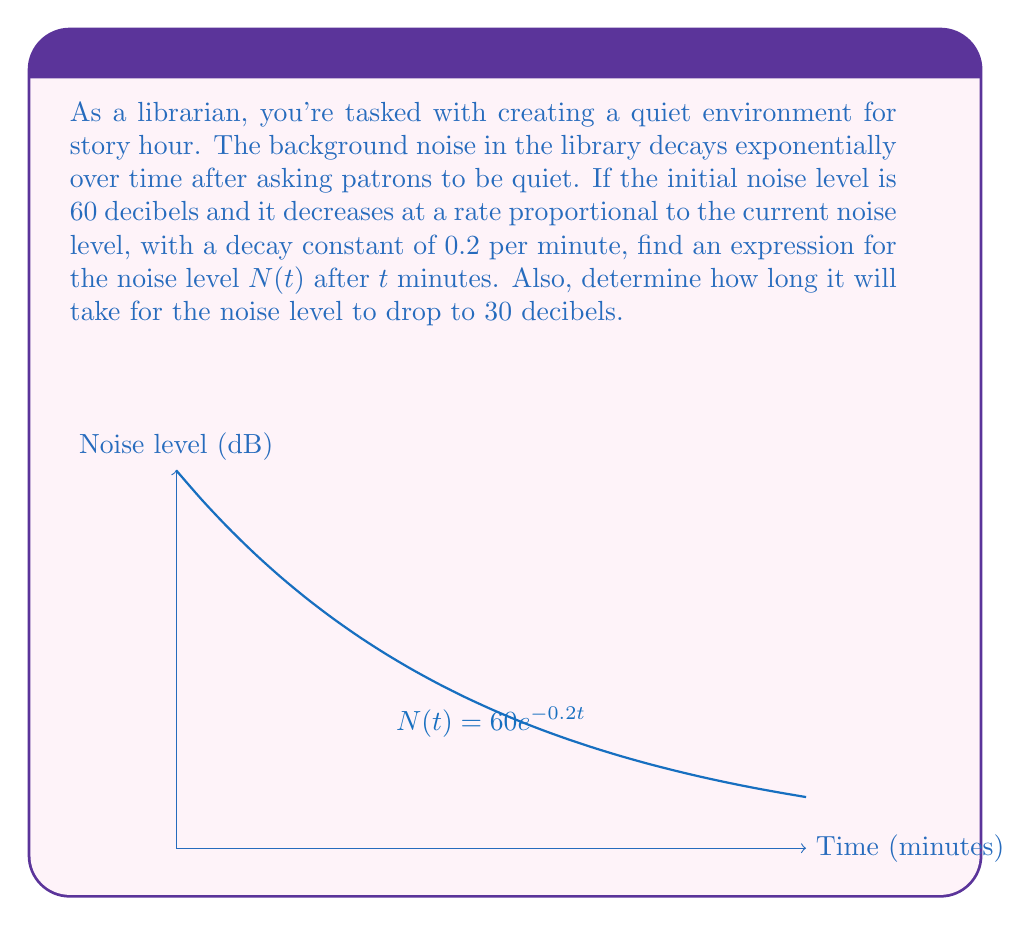Can you solve this math problem? Let's approach this step-by-step:

1) The rate of change of noise level is proportional to the current noise level. This can be expressed as:

   $$\frac{dN}{dt} = -kN$$

   where $k$ is the decay constant (0.2 per minute in this case).

2) This is a separable differential equation. Let's separate the variables:

   $$\frac{dN}{N} = -k dt$$

3) Integrate both sides:

   $$\int \frac{dN}{N} = -k \int dt$$

   $$\ln|N| = -kt + C$$

4) Solve for $N$:

   $$N = e^{-kt + C} = e^C \cdot e^{-kt}$$

5) Let $A = e^C$. Then our general solution is:

   $$N(t) = Ae^{-kt}$$

6) Use the initial condition: when $t=0$, $N=60$:

   $$60 = Ae^{-k(0)} = A$$

7) Therefore, our specific solution is:

   $$N(t) = 60e^{-0.2t}$$

8) To find when the noise level drops to 30 dB, solve:

   $$30 = 60e^{-0.2t}$$
   $$\frac{1}{2} = e^{-0.2t}$$
   $$\ln(\frac{1}{2}) = -0.2t$$
   $$t = -\frac{\ln(\frac{1}{2})}{0.2} \approx 3.47 \text{ minutes}$$
Answer: $N(t) = 60e^{-0.2t}$; 3.47 minutes 